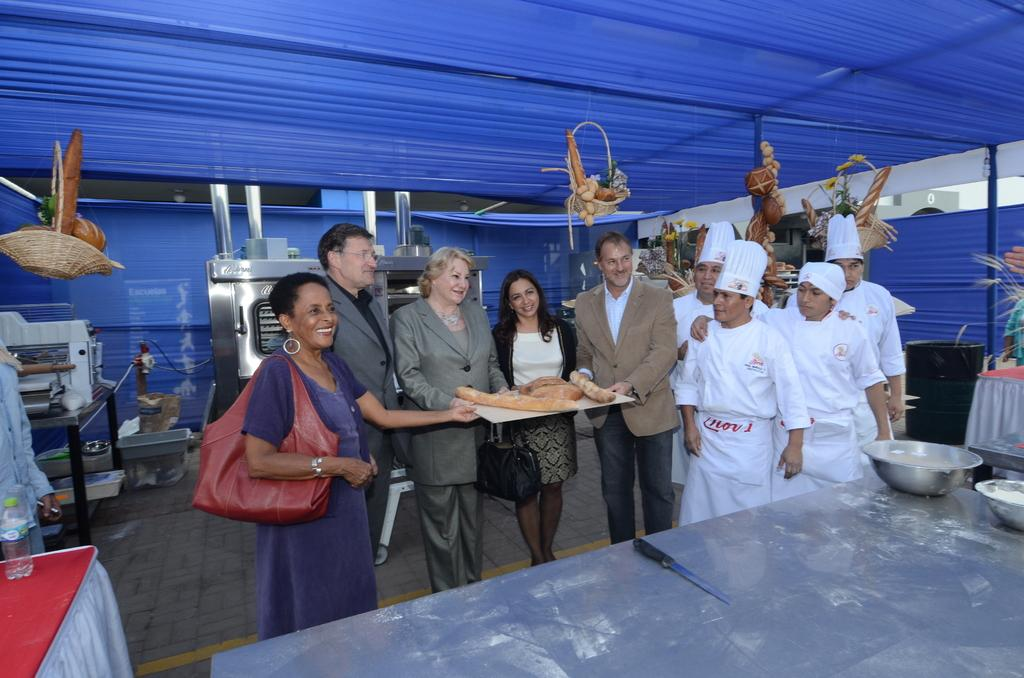How many people are in the group in the image? There is a group of people in the image, but the exact number is not specified. What are the roles of some of the people in the group? There are chefs in the group. What are the chefs holding in the image? The chefs are holding something, but the specific item is not mentioned. What is the color of the rooftop under which the group is standing? The group is standing under a blue rooftop. What is on the table in the image? There is a table in the image with many bowls on it, knives, and other machines. What grade did the chefs receive for their performance in the image? There is no mention of a performance or grade in the image. The chefs are simply holding something, and their performance or grade is not relevant to the image. 